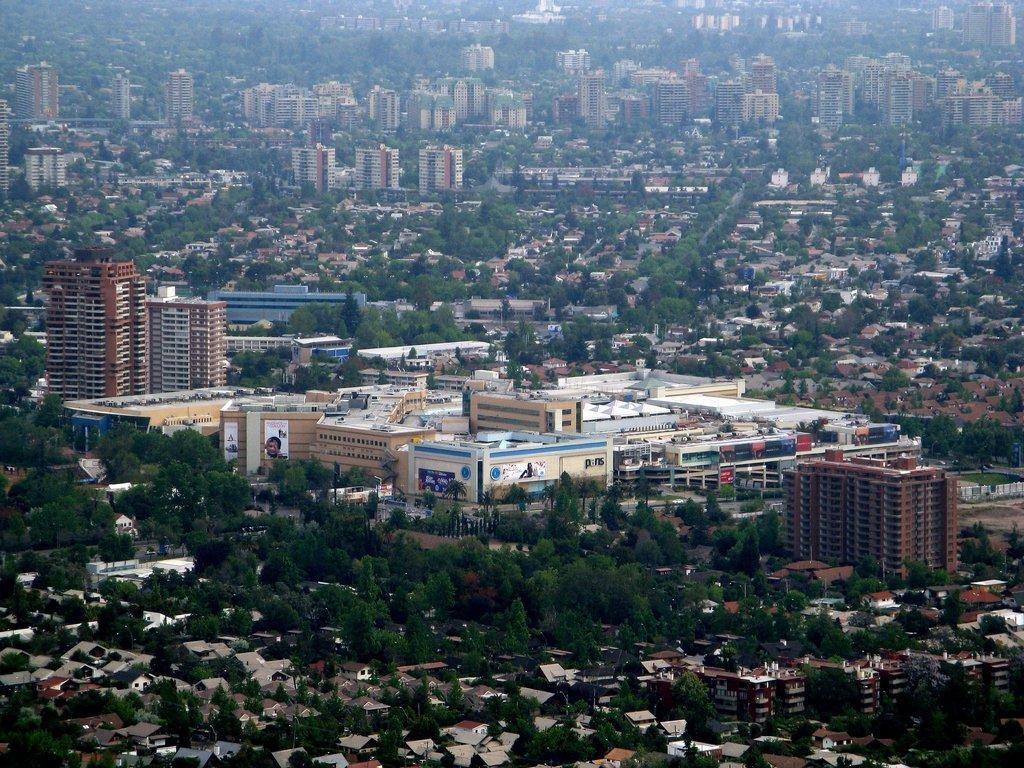How would you summarize this image in a sentence or two? In this image we can see trees and buildings. 